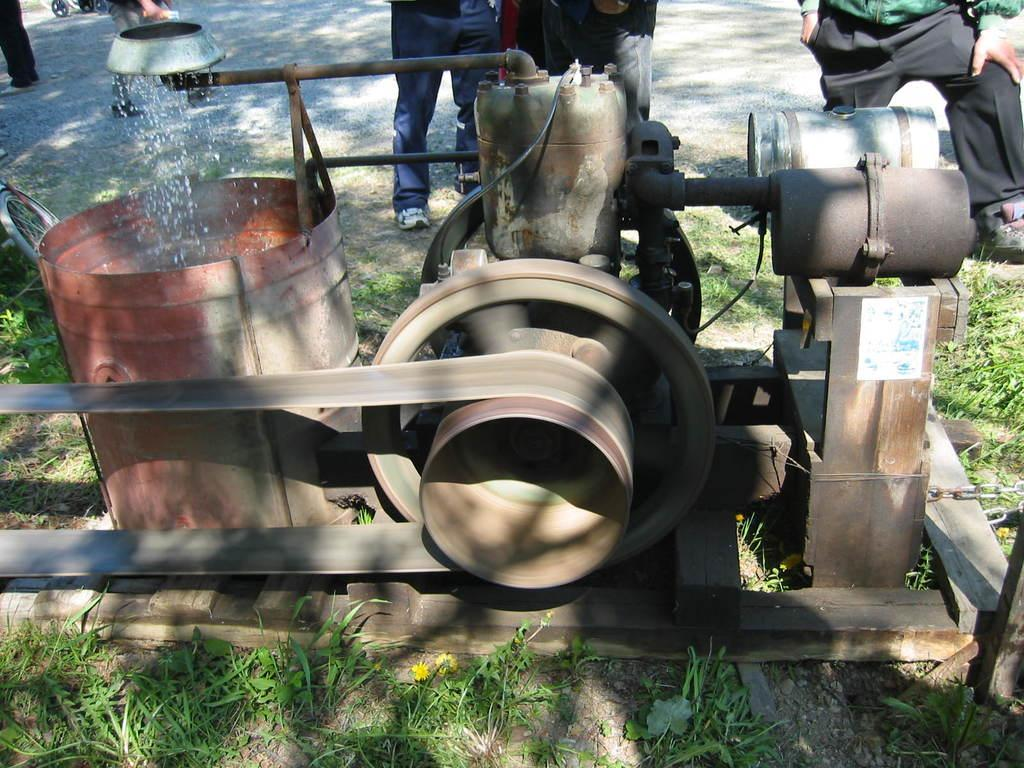What is the main object on the ground in the image? There is a machine on the ground in the image. Can you describe the people visible in the image? The people are visible in the background of the image. Where are the people located in relation to the machine? The people are on a road in the background of the image. What type of root can be seen growing near the machine in the image? There is no root visible in the image; it only features a machine on the ground and people on a road in the background. 